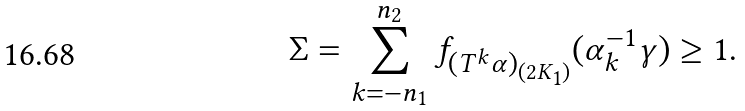<formula> <loc_0><loc_0><loc_500><loc_500>\Sigma = \sum _ { k = - n _ { 1 } } ^ { n _ { 2 } } f _ { ( T ^ { k } \alpha ) _ { ( 2 K _ { 1 } ) } } ( \alpha _ { k } ^ { - 1 } \gamma ) \geq 1 .</formula> 